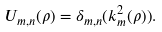<formula> <loc_0><loc_0><loc_500><loc_500>U _ { m , n } ( \rho ) = \delta _ { m , n } ( k ^ { 2 } _ { m } ( \rho ) ) .</formula> 